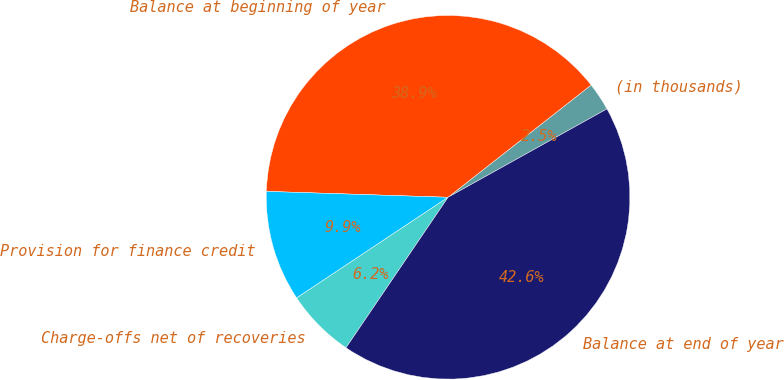Convert chart. <chart><loc_0><loc_0><loc_500><loc_500><pie_chart><fcel>(in thousands)<fcel>Balance at beginning of year<fcel>Provision for finance credit<fcel>Charge-offs net of recoveries<fcel>Balance at end of year<nl><fcel>2.51%<fcel>38.89%<fcel>9.85%<fcel>6.18%<fcel>42.56%<nl></chart> 